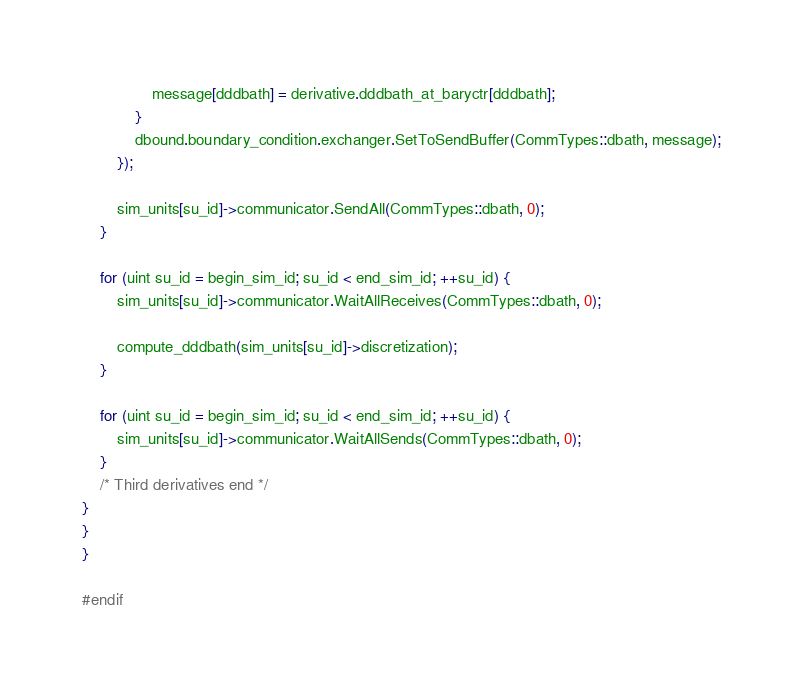<code> <loc_0><loc_0><loc_500><loc_500><_C++_>                message[dddbath] = derivative.dddbath_at_baryctr[dddbath];
            }
            dbound.boundary_condition.exchanger.SetToSendBuffer(CommTypes::dbath, message);
        });

        sim_units[su_id]->communicator.SendAll(CommTypes::dbath, 0);
    }

    for (uint su_id = begin_sim_id; su_id < end_sim_id; ++su_id) {
        sim_units[su_id]->communicator.WaitAllReceives(CommTypes::dbath, 0);

        compute_dddbath(sim_units[su_id]->discretization);
    }

    for (uint su_id = begin_sim_id; su_id < end_sim_id; ++su_id) {
        sim_units[su_id]->communicator.WaitAllSends(CommTypes::dbath, 0);
    }
    /* Third derivatives end */
}
}
}

#endif</code> 